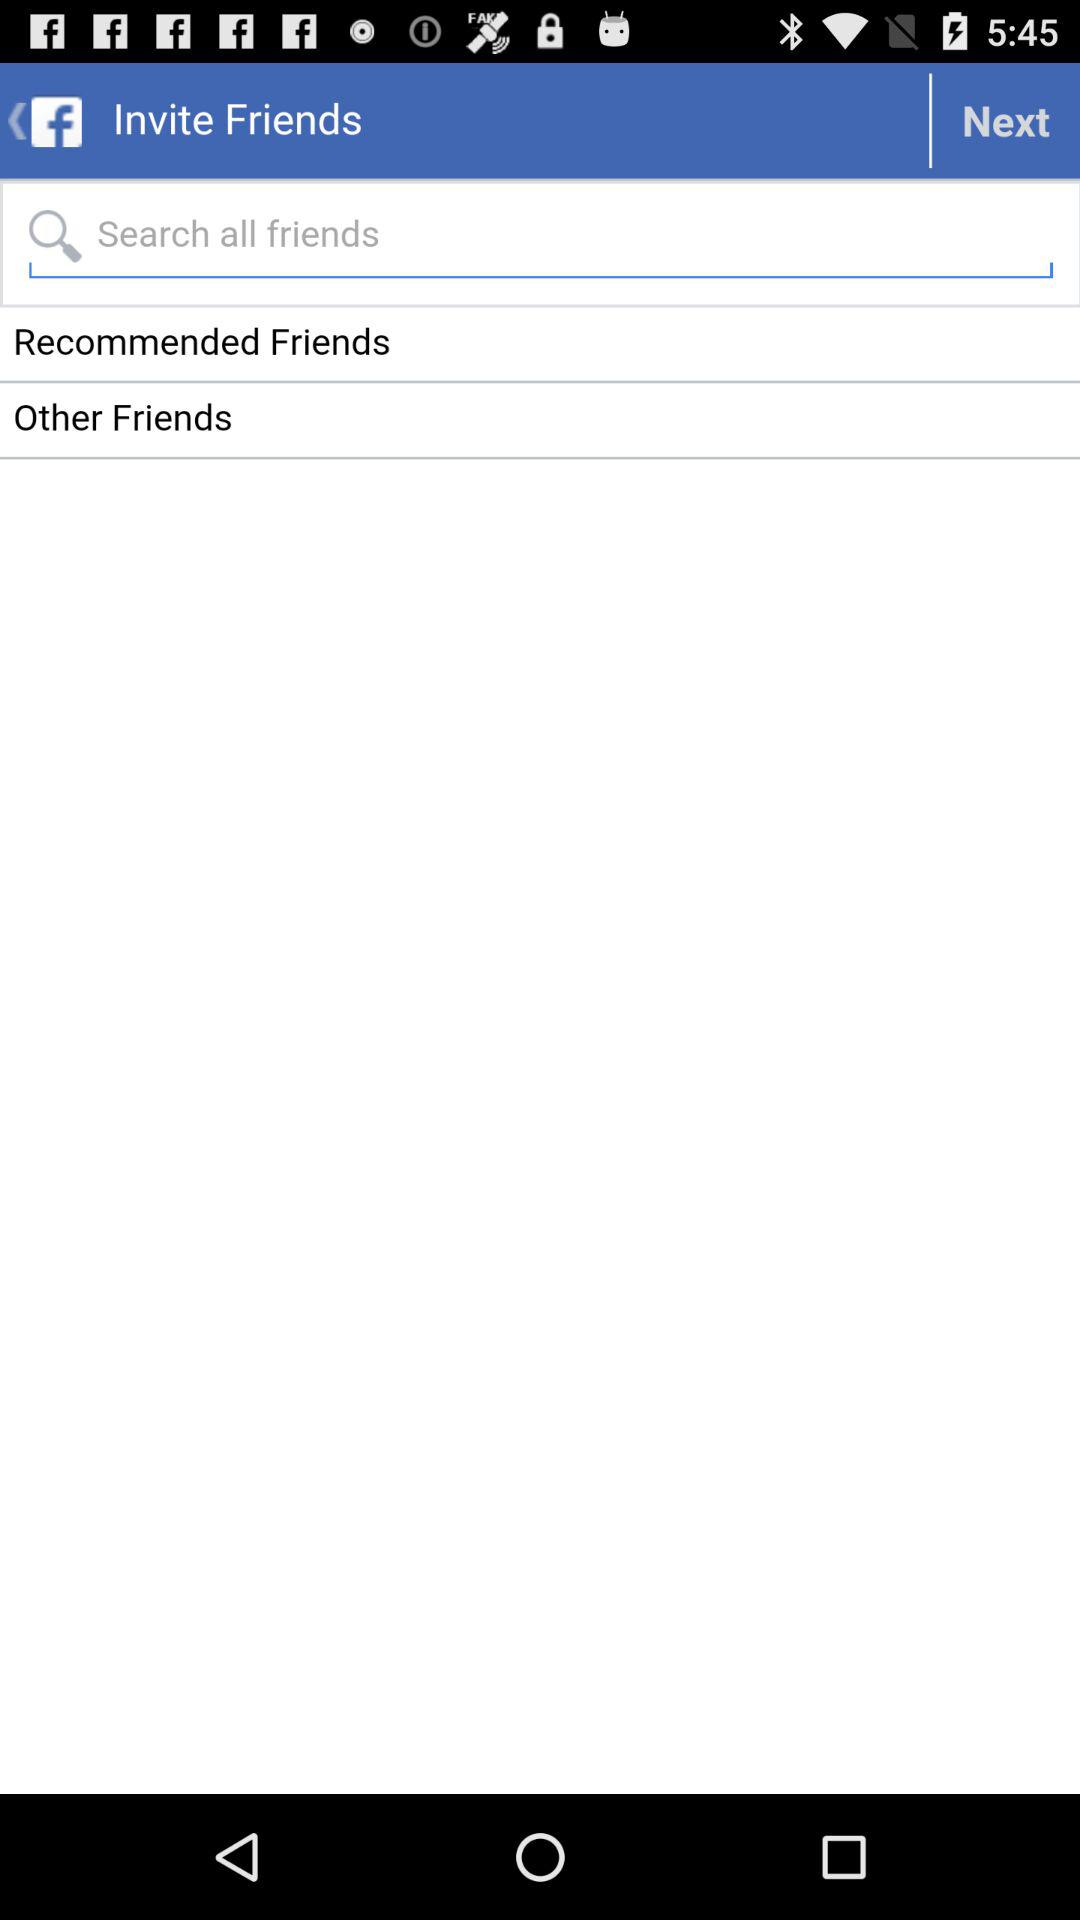What application allows me to invite friends? The application that allows you to invite friends is "Facebook". 